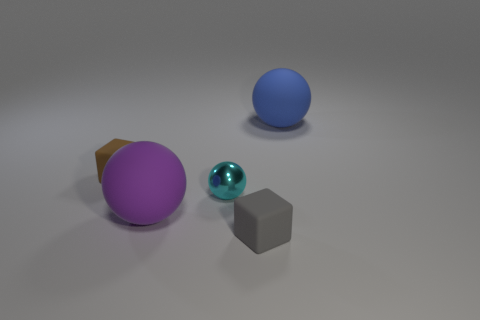There is a small matte thing to the left of the tiny gray object; is its shape the same as the tiny matte thing that is right of the small cyan metallic thing?
Your answer should be compact. Yes. Is there another big sphere made of the same material as the big purple sphere?
Give a very brief answer. Yes. How many cyan objects are large objects or small metallic things?
Give a very brief answer. 1. There is a rubber thing that is to the right of the metal sphere and in front of the small brown rubber cube; how big is it?
Your response must be concise. Small. Are there more spheres that are on the left side of the tiny metal sphere than cyan rubber spheres?
Give a very brief answer. Yes. What number of cubes are cyan objects or yellow objects?
Give a very brief answer. 0. What is the shape of the tiny thing that is to the left of the small gray block and right of the brown matte cube?
Give a very brief answer. Sphere. Are there an equal number of matte balls that are behind the gray block and cyan shiny spheres that are in front of the big purple sphere?
Your response must be concise. No. What number of objects are either gray rubber cubes or small cyan objects?
Offer a very short reply. 2. What color is the ball that is the same size as the purple object?
Give a very brief answer. Blue. 